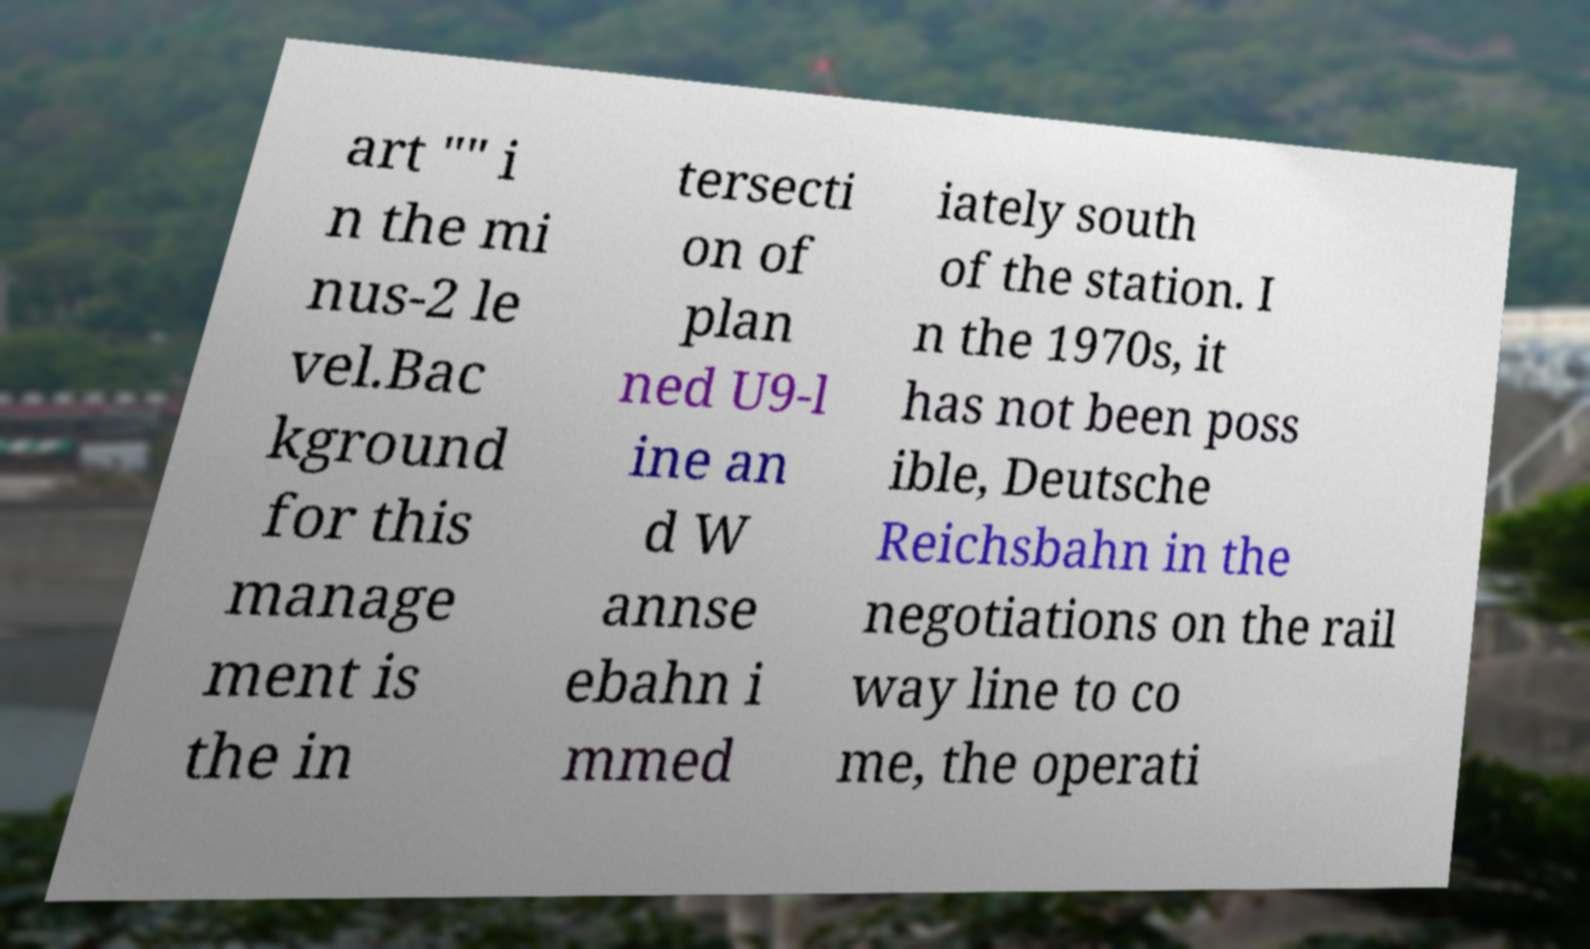Please read and relay the text visible in this image. What does it say? art "" i n the mi nus-2 le vel.Bac kground for this manage ment is the in tersecti on of plan ned U9-l ine an d W annse ebahn i mmed iately south of the station. I n the 1970s, it has not been poss ible, Deutsche Reichsbahn in the negotiations on the rail way line to co me, the operati 